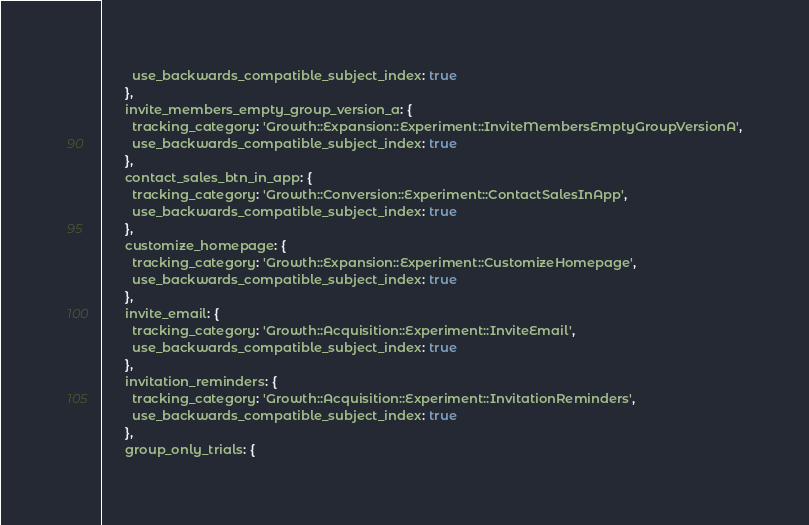Convert code to text. <code><loc_0><loc_0><loc_500><loc_500><_Ruby_>        use_backwards_compatible_subject_index: true
      },
      invite_members_empty_group_version_a: {
        tracking_category: 'Growth::Expansion::Experiment::InviteMembersEmptyGroupVersionA',
        use_backwards_compatible_subject_index: true
      },
      contact_sales_btn_in_app: {
        tracking_category: 'Growth::Conversion::Experiment::ContactSalesInApp',
        use_backwards_compatible_subject_index: true
      },
      customize_homepage: {
        tracking_category: 'Growth::Expansion::Experiment::CustomizeHomepage',
        use_backwards_compatible_subject_index: true
      },
      invite_email: {
        tracking_category: 'Growth::Acquisition::Experiment::InviteEmail',
        use_backwards_compatible_subject_index: true
      },
      invitation_reminders: {
        tracking_category: 'Growth::Acquisition::Experiment::InvitationReminders',
        use_backwards_compatible_subject_index: true
      },
      group_only_trials: {</code> 